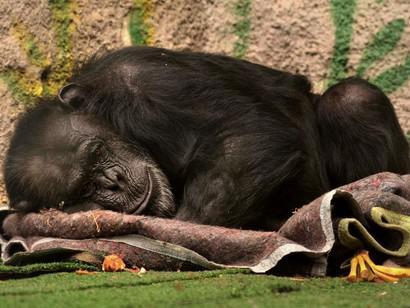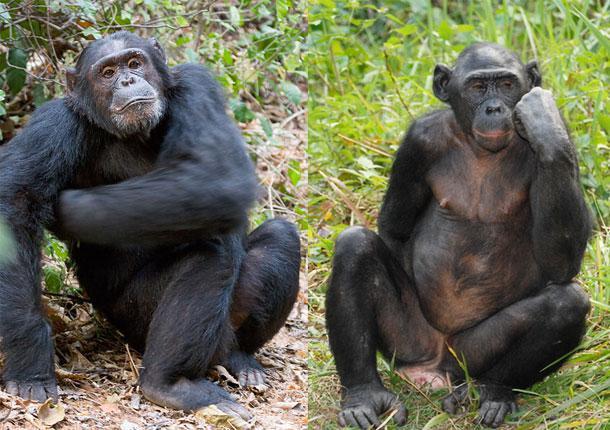The first image is the image on the left, the second image is the image on the right. Analyze the images presented: Is the assertion "A chimpanzee sleeps alone." valid? Answer yes or no. Yes. The first image is the image on the left, the second image is the image on the right. Evaluate the accuracy of this statement regarding the images: "The left image has at least one chimp lying down.". Is it true? Answer yes or no. Yes. 